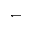Convert formula to latex. <formula><loc_0><loc_0><loc_500><loc_500>\leftharpoondown</formula> 